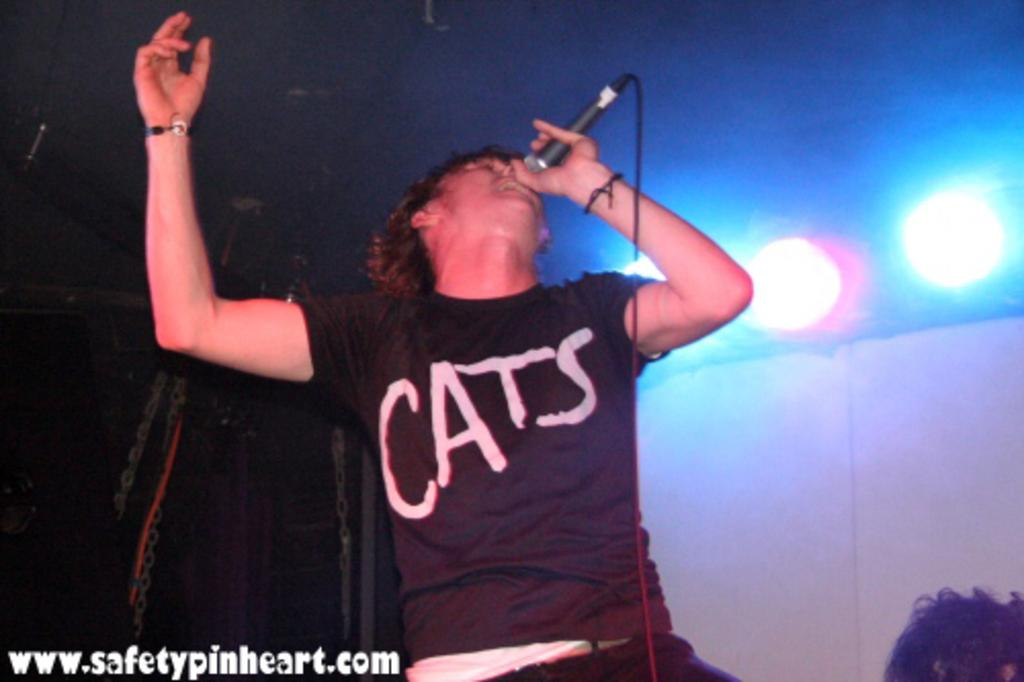What is the person in the image doing? The person is standing in the image and holding a microphone. What is the person wearing? The person is wearing a black t-shirt. What can be seen in the background of the image? There are lights visible in the background of the image. What type of iron is the person using in the image? There is no iron present in the image. What is the manager's role in the image? There is no manager mentioned or depicted in the image. 